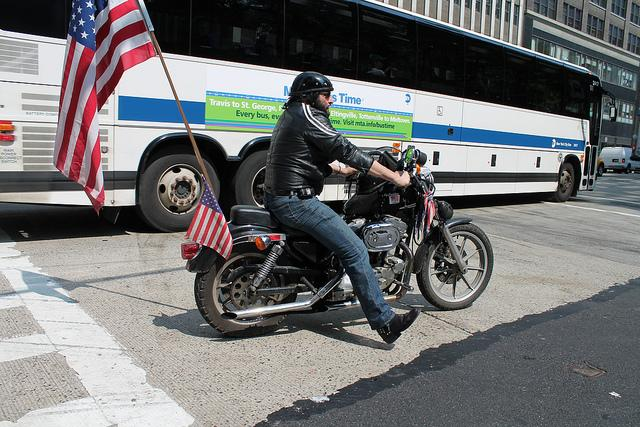Which one of these terms could be used to describe the motorcycle rider? patriotic 